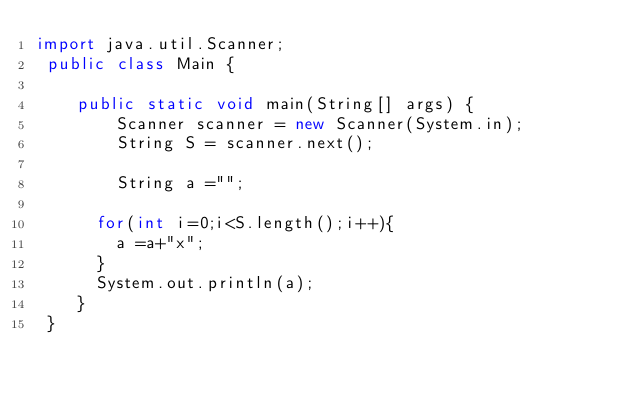Convert code to text. <code><loc_0><loc_0><loc_500><loc_500><_Java_>import java.util.Scanner;
 public class Main {
 
    public static void main(String[] args) {
        Scanner scanner = new Scanner(System.in);
        String S = scanner.next();
      
        String a ="";
      
      for(int i=0;i<S.length();i++){
        a =a+"x";
      }
      System.out.println(a);
    }
 }</code> 